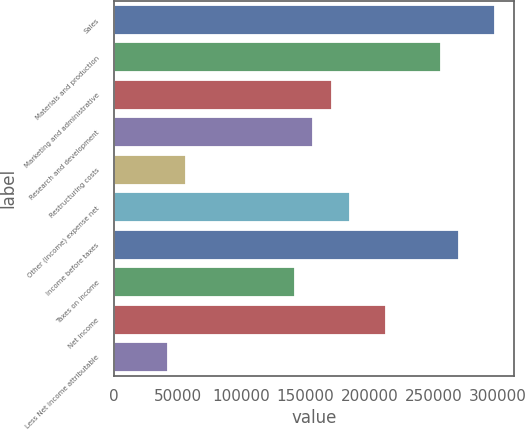<chart> <loc_0><loc_0><loc_500><loc_500><bar_chart><fcel>Sales<fcel>Materials and production<fcel>Marketing and administrative<fcel>Research and development<fcel>Restructuring costs<fcel>Other (income) expense net<fcel>Income before taxes<fcel>Taxes on income<fcel>Net income<fcel>Less Net income attributable<nl><fcel>298198<fcel>255599<fcel>170400<fcel>156200<fcel>56801.1<fcel>184599<fcel>269798<fcel>142000<fcel>212999<fcel>42601.2<nl></chart> 